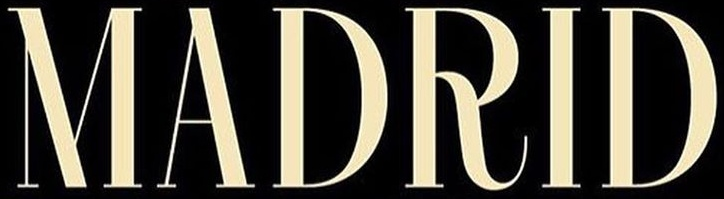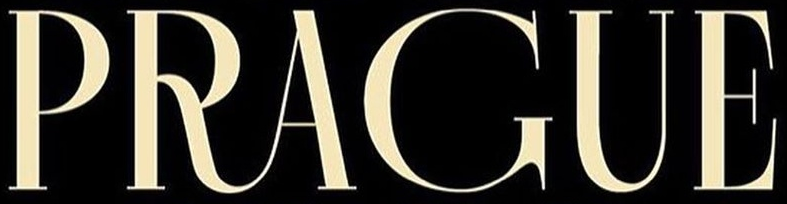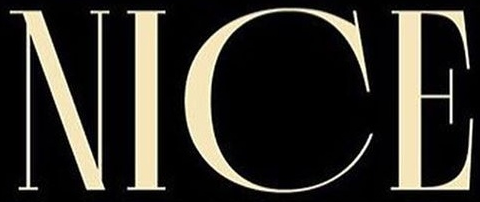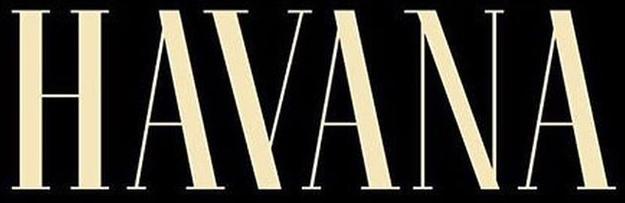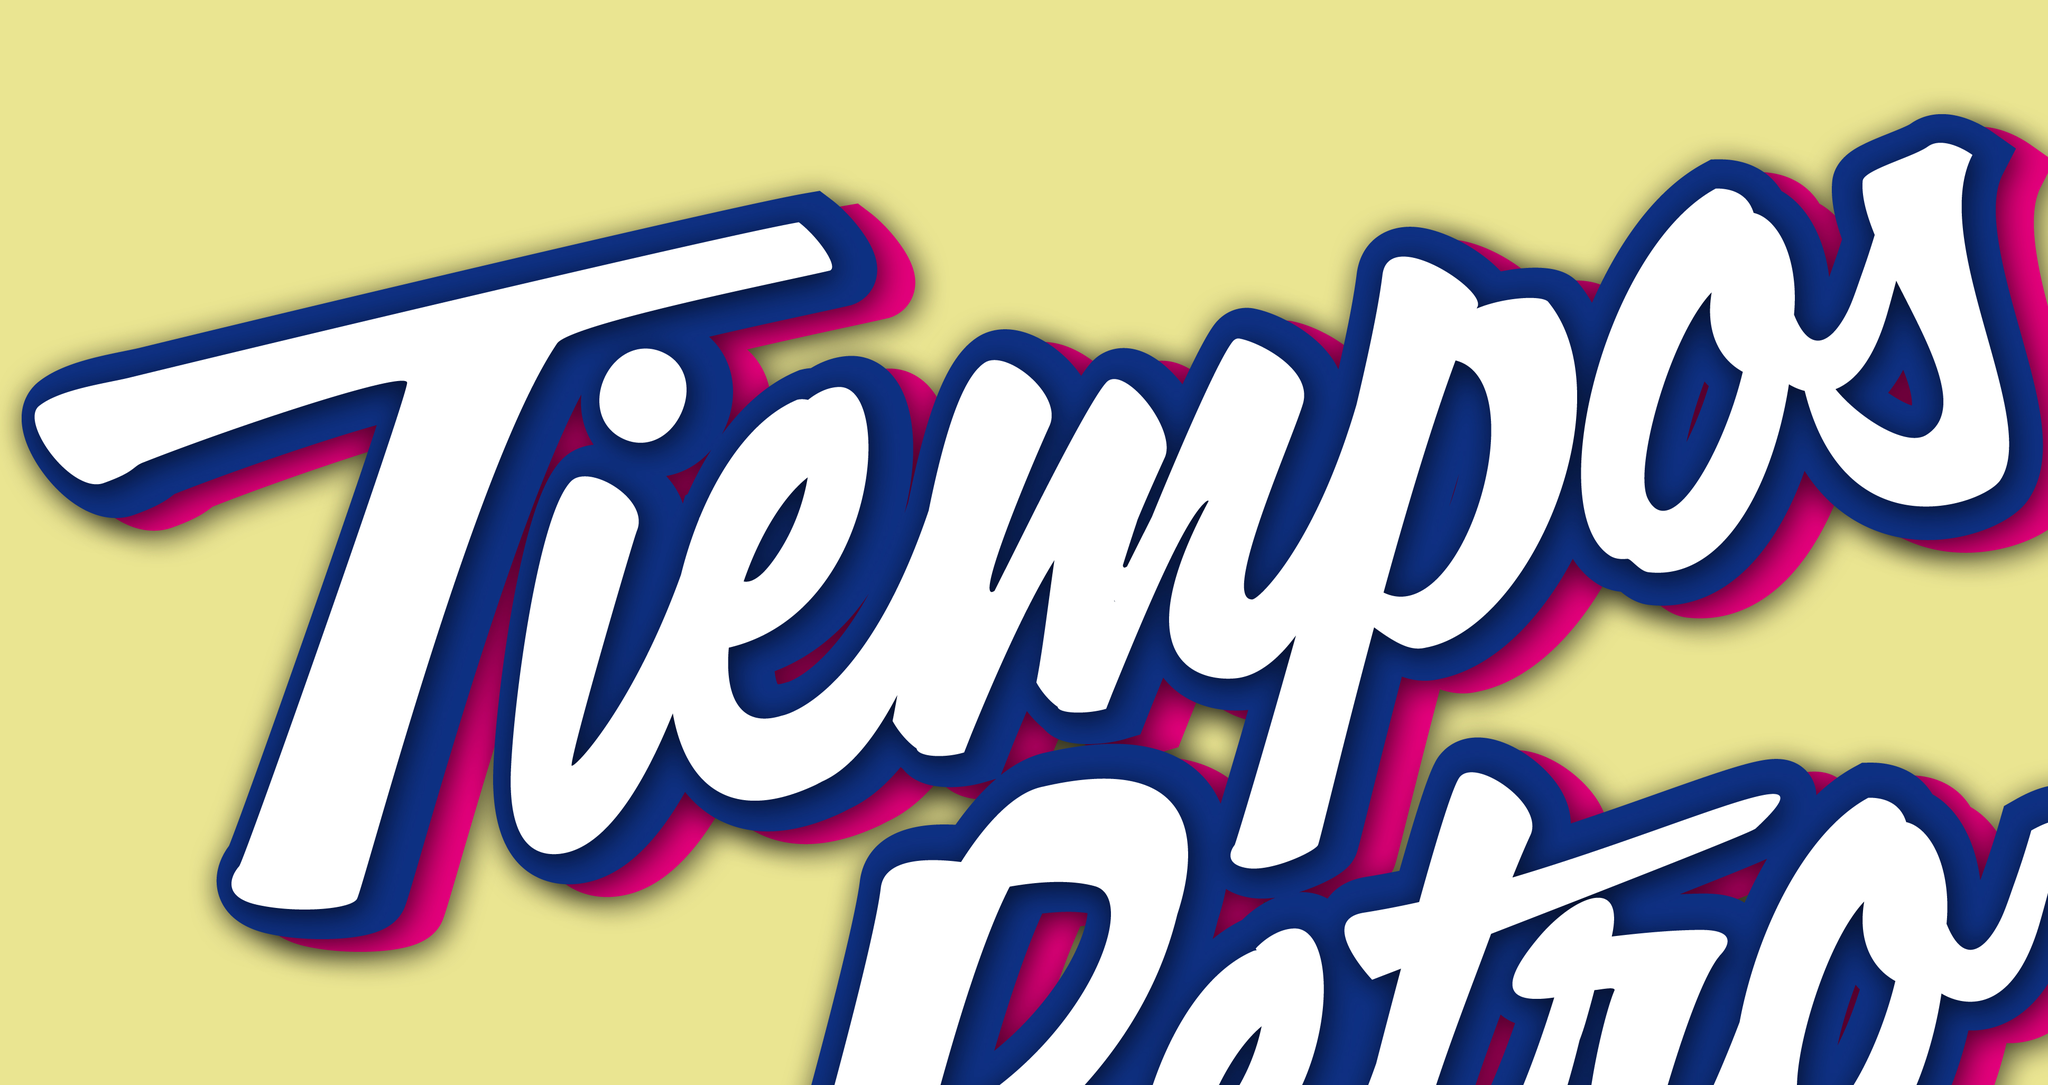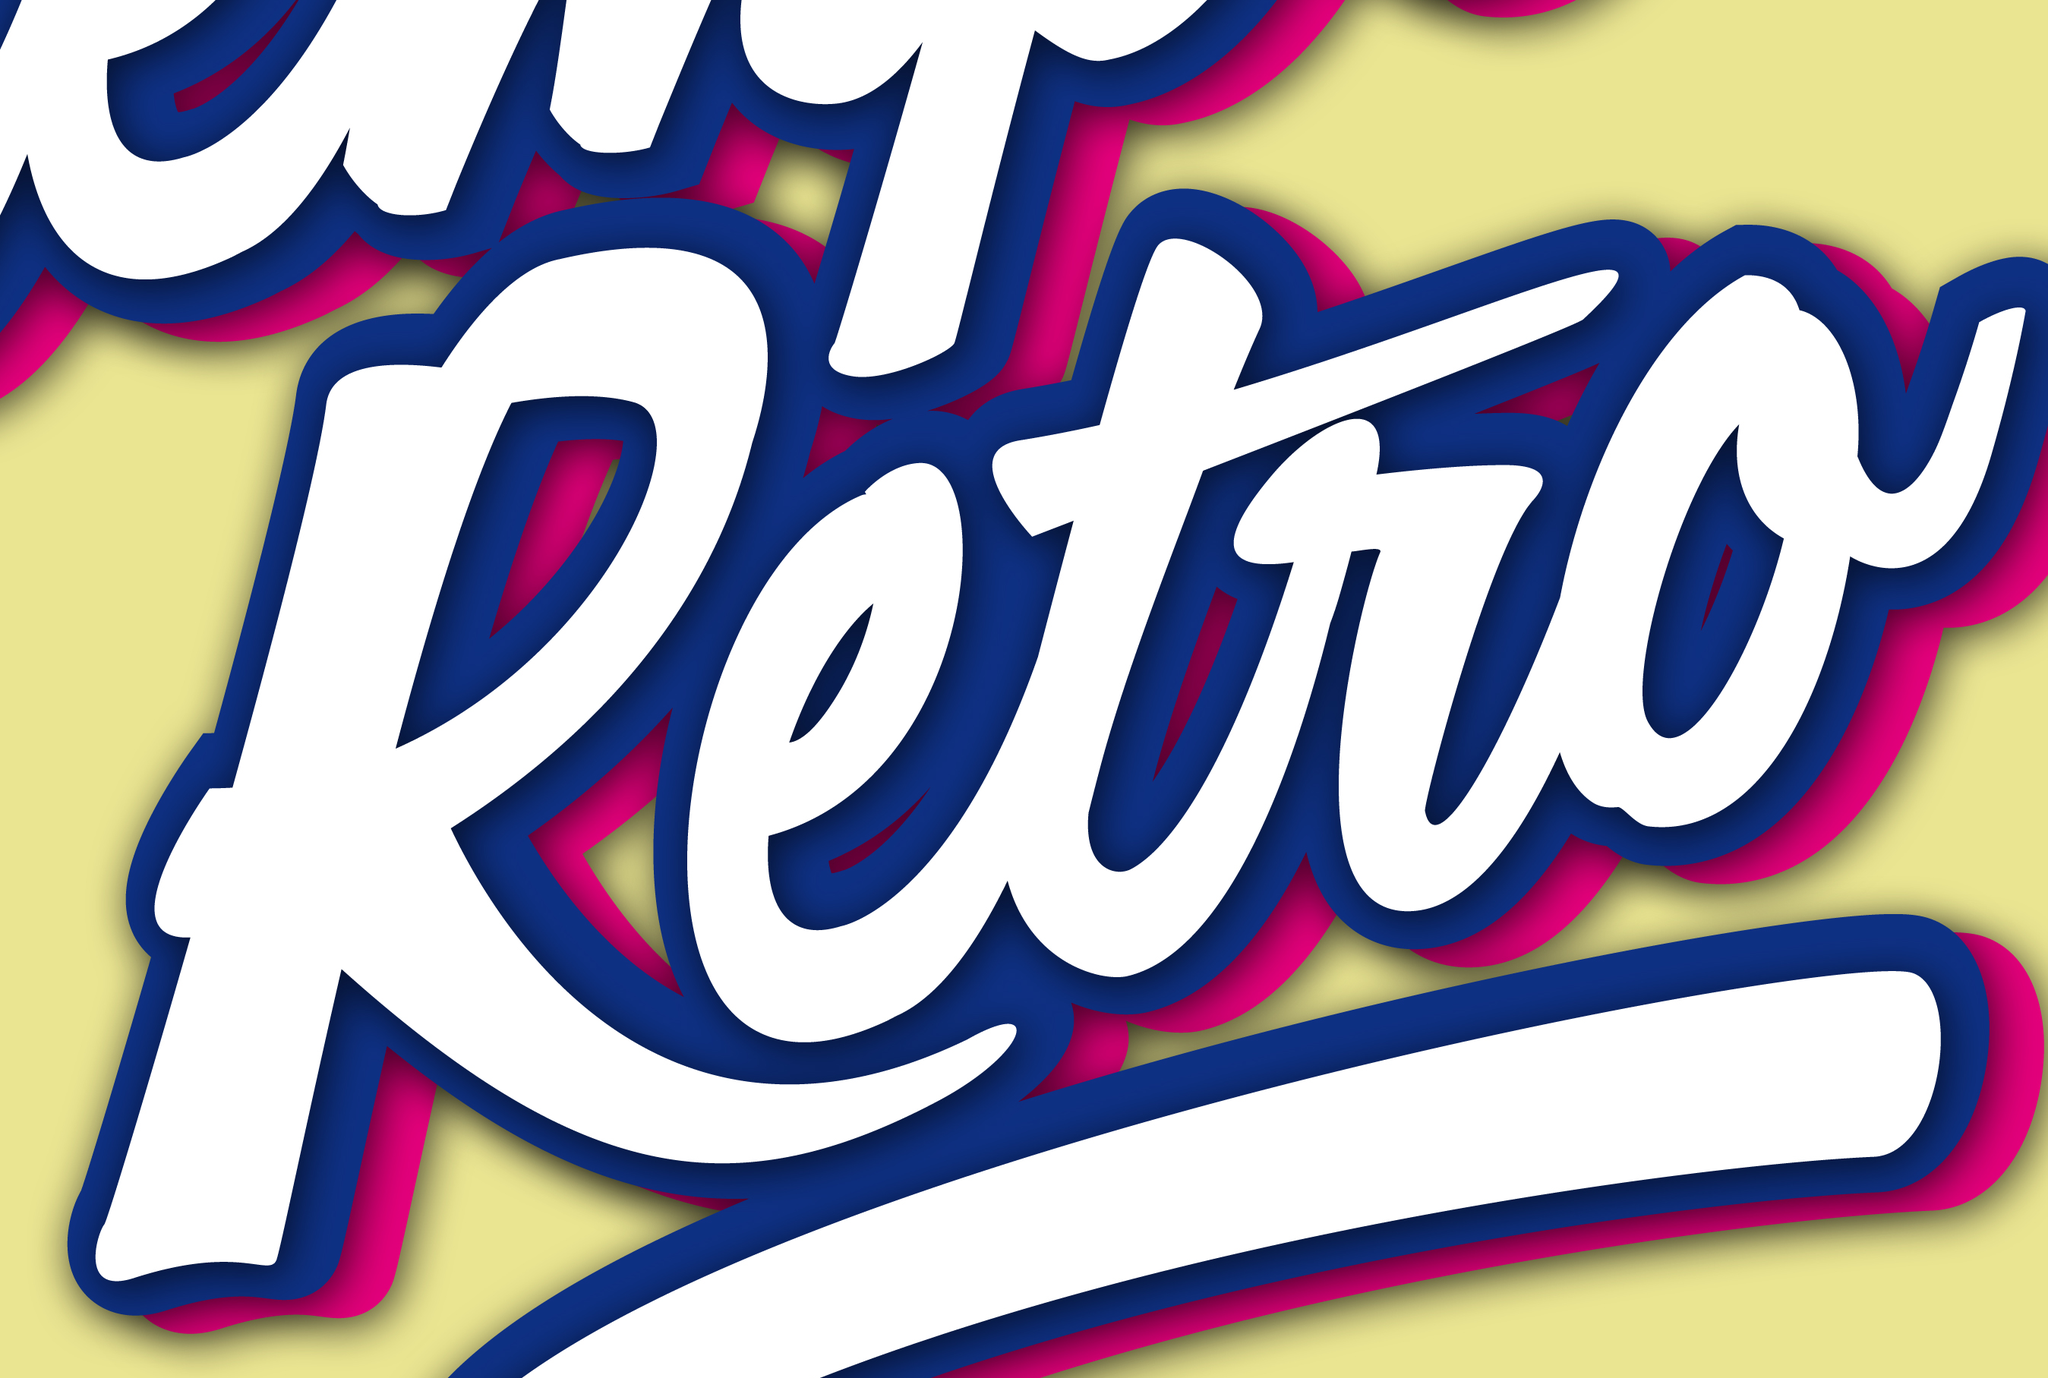Read the text content from these images in order, separated by a semicolon. MADRID; PRAGUE; NICE; HAYANA; Tiempos; Retro 